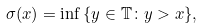Convert formula to latex. <formula><loc_0><loc_0><loc_500><loc_500>\sigma ( x ) = \inf \, \{ y \in { \mathbb { T } } \colon y > x \} ,</formula> 